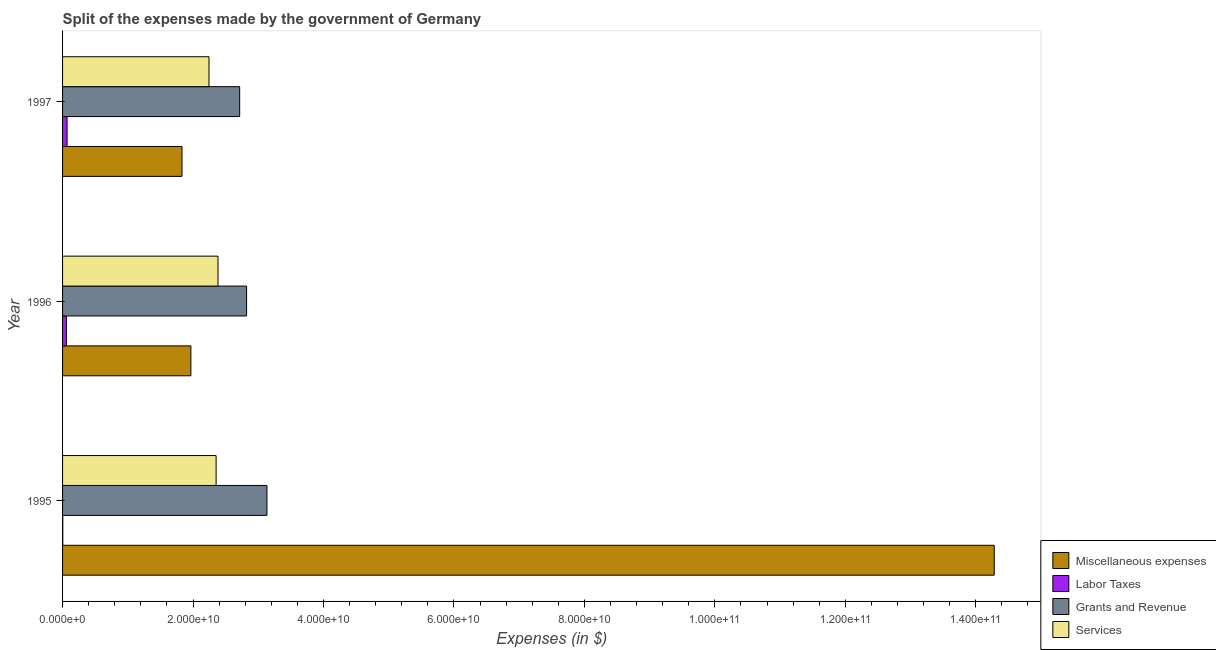How many groups of bars are there?
Your response must be concise. 3. Are the number of bars per tick equal to the number of legend labels?
Offer a terse response. Yes. How many bars are there on the 1st tick from the top?
Your answer should be compact. 4. What is the amount spent on grants and revenue in 1996?
Your answer should be very brief. 2.82e+1. Across all years, what is the maximum amount spent on labor taxes?
Offer a very short reply. 6.90e+08. Across all years, what is the minimum amount spent on miscellaneous expenses?
Give a very brief answer. 1.83e+1. In which year was the amount spent on services maximum?
Make the answer very short. 1996. What is the total amount spent on miscellaneous expenses in the graph?
Your answer should be very brief. 1.81e+11. What is the difference between the amount spent on labor taxes in 1995 and that in 1997?
Make the answer very short. -6.60e+08. What is the difference between the amount spent on grants and revenue in 1997 and the amount spent on services in 1996?
Your answer should be very brief. 3.32e+09. What is the average amount spent on miscellaneous expenses per year?
Your response must be concise. 6.03e+1. In the year 1995, what is the difference between the amount spent on services and amount spent on grants and revenue?
Your answer should be compact. -7.79e+09. What is the ratio of the amount spent on miscellaneous expenses in 1995 to that in 1996?
Your answer should be compact. 7.26. What is the difference between the highest and the second highest amount spent on services?
Make the answer very short. 2.90e+08. What is the difference between the highest and the lowest amount spent on miscellaneous expenses?
Offer a very short reply. 1.25e+11. Is the sum of the amount spent on services in 1996 and 1997 greater than the maximum amount spent on grants and revenue across all years?
Your response must be concise. Yes. What does the 3rd bar from the top in 1997 represents?
Your answer should be very brief. Labor Taxes. What does the 2nd bar from the bottom in 1995 represents?
Give a very brief answer. Labor Taxes. How many bars are there?
Keep it short and to the point. 12. Does the graph contain any zero values?
Provide a short and direct response. No. Does the graph contain grids?
Make the answer very short. No. How many legend labels are there?
Your response must be concise. 4. How are the legend labels stacked?
Your answer should be compact. Vertical. What is the title of the graph?
Offer a terse response. Split of the expenses made by the government of Germany. What is the label or title of the X-axis?
Ensure brevity in your answer.  Expenses (in $). What is the label or title of the Y-axis?
Give a very brief answer. Year. What is the Expenses (in $) of Miscellaneous expenses in 1995?
Provide a succinct answer. 1.43e+11. What is the Expenses (in $) of Labor Taxes in 1995?
Keep it short and to the point. 3.00e+07. What is the Expenses (in $) of Grants and Revenue in 1995?
Your response must be concise. 3.13e+1. What is the Expenses (in $) of Services in 1995?
Make the answer very short. 2.35e+1. What is the Expenses (in $) in Miscellaneous expenses in 1996?
Ensure brevity in your answer.  1.97e+1. What is the Expenses (in $) in Labor Taxes in 1996?
Your answer should be compact. 5.90e+08. What is the Expenses (in $) of Grants and Revenue in 1996?
Provide a succinct answer. 2.82e+1. What is the Expenses (in $) in Services in 1996?
Your answer should be compact. 2.38e+1. What is the Expenses (in $) of Miscellaneous expenses in 1997?
Give a very brief answer. 1.83e+1. What is the Expenses (in $) of Labor Taxes in 1997?
Offer a terse response. 6.90e+08. What is the Expenses (in $) of Grants and Revenue in 1997?
Your answer should be compact. 2.72e+1. What is the Expenses (in $) in Services in 1997?
Your response must be concise. 2.24e+1. Across all years, what is the maximum Expenses (in $) in Miscellaneous expenses?
Your answer should be very brief. 1.43e+11. Across all years, what is the maximum Expenses (in $) in Labor Taxes?
Your response must be concise. 6.90e+08. Across all years, what is the maximum Expenses (in $) in Grants and Revenue?
Keep it short and to the point. 3.13e+1. Across all years, what is the maximum Expenses (in $) of Services?
Offer a very short reply. 2.38e+1. Across all years, what is the minimum Expenses (in $) in Miscellaneous expenses?
Your answer should be very brief. 1.83e+1. Across all years, what is the minimum Expenses (in $) in Labor Taxes?
Your response must be concise. 3.00e+07. Across all years, what is the minimum Expenses (in $) of Grants and Revenue?
Make the answer very short. 2.72e+1. Across all years, what is the minimum Expenses (in $) of Services?
Your answer should be compact. 2.24e+1. What is the total Expenses (in $) in Miscellaneous expenses in the graph?
Your response must be concise. 1.81e+11. What is the total Expenses (in $) in Labor Taxes in the graph?
Your answer should be compact. 1.31e+09. What is the total Expenses (in $) in Grants and Revenue in the graph?
Ensure brevity in your answer.  8.67e+1. What is the total Expenses (in $) of Services in the graph?
Your answer should be very brief. 6.98e+1. What is the difference between the Expenses (in $) in Miscellaneous expenses in 1995 and that in 1996?
Offer a very short reply. 1.23e+11. What is the difference between the Expenses (in $) in Labor Taxes in 1995 and that in 1996?
Provide a short and direct response. -5.60e+08. What is the difference between the Expenses (in $) in Grants and Revenue in 1995 and that in 1996?
Ensure brevity in your answer.  3.12e+09. What is the difference between the Expenses (in $) in Services in 1995 and that in 1996?
Make the answer very short. -2.90e+08. What is the difference between the Expenses (in $) in Miscellaneous expenses in 1995 and that in 1997?
Provide a succinct answer. 1.25e+11. What is the difference between the Expenses (in $) of Labor Taxes in 1995 and that in 1997?
Offer a terse response. -6.60e+08. What is the difference between the Expenses (in $) in Grants and Revenue in 1995 and that in 1997?
Give a very brief answer. 4.18e+09. What is the difference between the Expenses (in $) of Services in 1995 and that in 1997?
Your answer should be compact. 1.09e+09. What is the difference between the Expenses (in $) in Miscellaneous expenses in 1996 and that in 1997?
Provide a succinct answer. 1.36e+09. What is the difference between the Expenses (in $) of Labor Taxes in 1996 and that in 1997?
Make the answer very short. -1.00e+08. What is the difference between the Expenses (in $) in Grants and Revenue in 1996 and that in 1997?
Make the answer very short. 1.06e+09. What is the difference between the Expenses (in $) in Services in 1996 and that in 1997?
Your answer should be compact. 1.38e+09. What is the difference between the Expenses (in $) in Miscellaneous expenses in 1995 and the Expenses (in $) in Labor Taxes in 1996?
Provide a succinct answer. 1.42e+11. What is the difference between the Expenses (in $) of Miscellaneous expenses in 1995 and the Expenses (in $) of Grants and Revenue in 1996?
Offer a terse response. 1.15e+11. What is the difference between the Expenses (in $) in Miscellaneous expenses in 1995 and the Expenses (in $) in Services in 1996?
Make the answer very short. 1.19e+11. What is the difference between the Expenses (in $) of Labor Taxes in 1995 and the Expenses (in $) of Grants and Revenue in 1996?
Offer a very short reply. -2.82e+1. What is the difference between the Expenses (in $) of Labor Taxes in 1995 and the Expenses (in $) of Services in 1996?
Give a very brief answer. -2.38e+1. What is the difference between the Expenses (in $) in Grants and Revenue in 1995 and the Expenses (in $) in Services in 1996?
Provide a short and direct response. 7.50e+09. What is the difference between the Expenses (in $) of Miscellaneous expenses in 1995 and the Expenses (in $) of Labor Taxes in 1997?
Provide a short and direct response. 1.42e+11. What is the difference between the Expenses (in $) in Miscellaneous expenses in 1995 and the Expenses (in $) in Grants and Revenue in 1997?
Make the answer very short. 1.16e+11. What is the difference between the Expenses (in $) of Miscellaneous expenses in 1995 and the Expenses (in $) of Services in 1997?
Provide a short and direct response. 1.20e+11. What is the difference between the Expenses (in $) in Labor Taxes in 1995 and the Expenses (in $) in Grants and Revenue in 1997?
Give a very brief answer. -2.71e+1. What is the difference between the Expenses (in $) of Labor Taxes in 1995 and the Expenses (in $) of Services in 1997?
Offer a very short reply. -2.24e+1. What is the difference between the Expenses (in $) in Grants and Revenue in 1995 and the Expenses (in $) in Services in 1997?
Your answer should be compact. 8.88e+09. What is the difference between the Expenses (in $) in Miscellaneous expenses in 1996 and the Expenses (in $) in Labor Taxes in 1997?
Provide a short and direct response. 1.90e+1. What is the difference between the Expenses (in $) of Miscellaneous expenses in 1996 and the Expenses (in $) of Grants and Revenue in 1997?
Keep it short and to the point. -7.48e+09. What is the difference between the Expenses (in $) in Miscellaneous expenses in 1996 and the Expenses (in $) in Services in 1997?
Give a very brief answer. -2.78e+09. What is the difference between the Expenses (in $) of Labor Taxes in 1996 and the Expenses (in $) of Grants and Revenue in 1997?
Keep it short and to the point. -2.66e+1. What is the difference between the Expenses (in $) in Labor Taxes in 1996 and the Expenses (in $) in Services in 1997?
Give a very brief answer. -2.19e+1. What is the difference between the Expenses (in $) of Grants and Revenue in 1996 and the Expenses (in $) of Services in 1997?
Your answer should be very brief. 5.76e+09. What is the average Expenses (in $) of Miscellaneous expenses per year?
Offer a very short reply. 6.03e+1. What is the average Expenses (in $) of Labor Taxes per year?
Provide a short and direct response. 4.37e+08. What is the average Expenses (in $) in Grants and Revenue per year?
Ensure brevity in your answer.  2.89e+1. What is the average Expenses (in $) of Services per year?
Make the answer very short. 2.33e+1. In the year 1995, what is the difference between the Expenses (in $) in Miscellaneous expenses and Expenses (in $) in Labor Taxes?
Offer a very short reply. 1.43e+11. In the year 1995, what is the difference between the Expenses (in $) in Miscellaneous expenses and Expenses (in $) in Grants and Revenue?
Your answer should be compact. 1.11e+11. In the year 1995, what is the difference between the Expenses (in $) in Miscellaneous expenses and Expenses (in $) in Services?
Provide a short and direct response. 1.19e+11. In the year 1995, what is the difference between the Expenses (in $) of Labor Taxes and Expenses (in $) of Grants and Revenue?
Your answer should be very brief. -3.13e+1. In the year 1995, what is the difference between the Expenses (in $) of Labor Taxes and Expenses (in $) of Services?
Provide a succinct answer. -2.35e+1. In the year 1995, what is the difference between the Expenses (in $) of Grants and Revenue and Expenses (in $) of Services?
Offer a terse response. 7.79e+09. In the year 1996, what is the difference between the Expenses (in $) of Miscellaneous expenses and Expenses (in $) of Labor Taxes?
Offer a terse response. 1.91e+1. In the year 1996, what is the difference between the Expenses (in $) in Miscellaneous expenses and Expenses (in $) in Grants and Revenue?
Keep it short and to the point. -8.54e+09. In the year 1996, what is the difference between the Expenses (in $) in Miscellaneous expenses and Expenses (in $) in Services?
Give a very brief answer. -4.16e+09. In the year 1996, what is the difference between the Expenses (in $) in Labor Taxes and Expenses (in $) in Grants and Revenue?
Make the answer very short. -2.76e+1. In the year 1996, what is the difference between the Expenses (in $) in Labor Taxes and Expenses (in $) in Services?
Provide a short and direct response. -2.32e+1. In the year 1996, what is the difference between the Expenses (in $) of Grants and Revenue and Expenses (in $) of Services?
Offer a very short reply. 4.38e+09. In the year 1997, what is the difference between the Expenses (in $) in Miscellaneous expenses and Expenses (in $) in Labor Taxes?
Provide a succinct answer. 1.76e+1. In the year 1997, what is the difference between the Expenses (in $) in Miscellaneous expenses and Expenses (in $) in Grants and Revenue?
Provide a short and direct response. -8.84e+09. In the year 1997, what is the difference between the Expenses (in $) in Miscellaneous expenses and Expenses (in $) in Services?
Your response must be concise. -4.14e+09. In the year 1997, what is the difference between the Expenses (in $) of Labor Taxes and Expenses (in $) of Grants and Revenue?
Your response must be concise. -2.65e+1. In the year 1997, what is the difference between the Expenses (in $) of Labor Taxes and Expenses (in $) of Services?
Give a very brief answer. -2.18e+1. In the year 1997, what is the difference between the Expenses (in $) in Grants and Revenue and Expenses (in $) in Services?
Offer a terse response. 4.70e+09. What is the ratio of the Expenses (in $) of Miscellaneous expenses in 1995 to that in 1996?
Provide a succinct answer. 7.26. What is the ratio of the Expenses (in $) in Labor Taxes in 1995 to that in 1996?
Keep it short and to the point. 0.05. What is the ratio of the Expenses (in $) of Grants and Revenue in 1995 to that in 1996?
Provide a short and direct response. 1.11. What is the ratio of the Expenses (in $) of Services in 1995 to that in 1996?
Give a very brief answer. 0.99. What is the ratio of the Expenses (in $) of Miscellaneous expenses in 1995 to that in 1997?
Provide a succinct answer. 7.8. What is the ratio of the Expenses (in $) in Labor Taxes in 1995 to that in 1997?
Provide a short and direct response. 0.04. What is the ratio of the Expenses (in $) in Grants and Revenue in 1995 to that in 1997?
Provide a succinct answer. 1.15. What is the ratio of the Expenses (in $) of Services in 1995 to that in 1997?
Provide a short and direct response. 1.05. What is the ratio of the Expenses (in $) in Miscellaneous expenses in 1996 to that in 1997?
Keep it short and to the point. 1.07. What is the ratio of the Expenses (in $) of Labor Taxes in 1996 to that in 1997?
Give a very brief answer. 0.86. What is the ratio of the Expenses (in $) in Grants and Revenue in 1996 to that in 1997?
Ensure brevity in your answer.  1.04. What is the ratio of the Expenses (in $) of Services in 1996 to that in 1997?
Keep it short and to the point. 1.06. What is the difference between the highest and the second highest Expenses (in $) of Miscellaneous expenses?
Your response must be concise. 1.23e+11. What is the difference between the highest and the second highest Expenses (in $) in Grants and Revenue?
Offer a terse response. 3.12e+09. What is the difference between the highest and the second highest Expenses (in $) of Services?
Keep it short and to the point. 2.90e+08. What is the difference between the highest and the lowest Expenses (in $) in Miscellaneous expenses?
Keep it short and to the point. 1.25e+11. What is the difference between the highest and the lowest Expenses (in $) of Labor Taxes?
Make the answer very short. 6.60e+08. What is the difference between the highest and the lowest Expenses (in $) in Grants and Revenue?
Provide a succinct answer. 4.18e+09. What is the difference between the highest and the lowest Expenses (in $) of Services?
Offer a very short reply. 1.38e+09. 